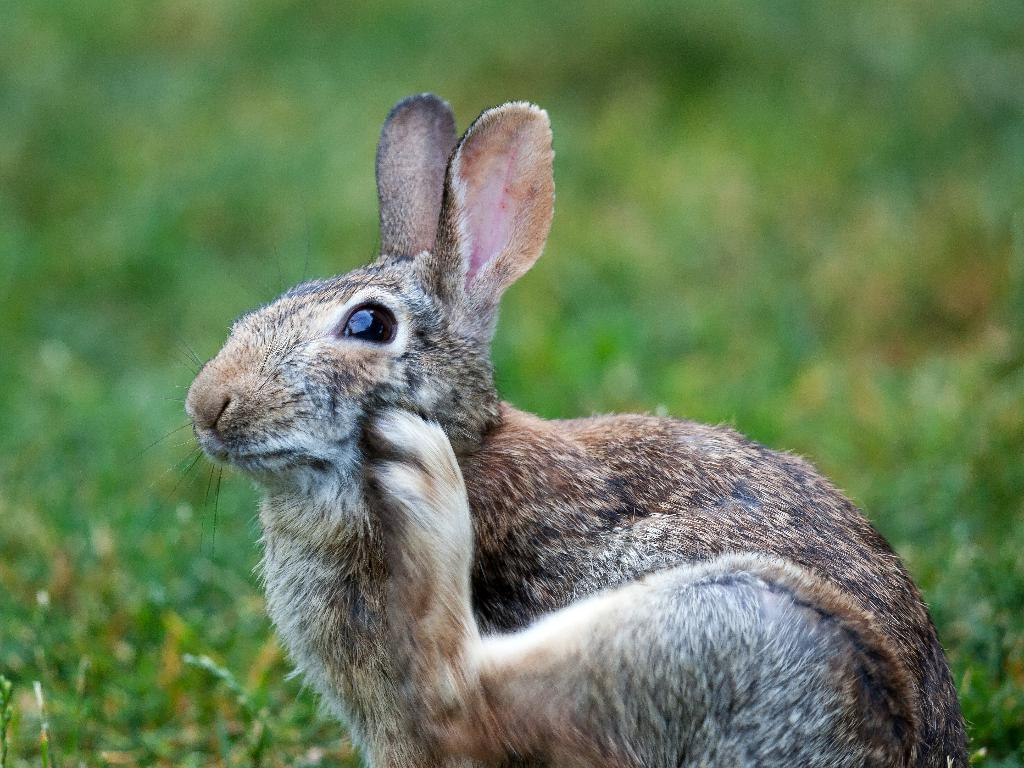What animal is present in the image? There is a rabbit in the image. Where is the rabbit located? The rabbit is on the grass. How many cakes are being held by the rabbit in the image? There are no cakes present in the image, and the rabbit is not holding anything. 